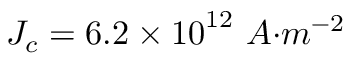<formula> <loc_0><loc_0><loc_500><loc_500>J _ { c } = 6 . 2 \times { 1 0 } ^ { 1 2 } \ { A { m } ^ { - 2 }</formula> 